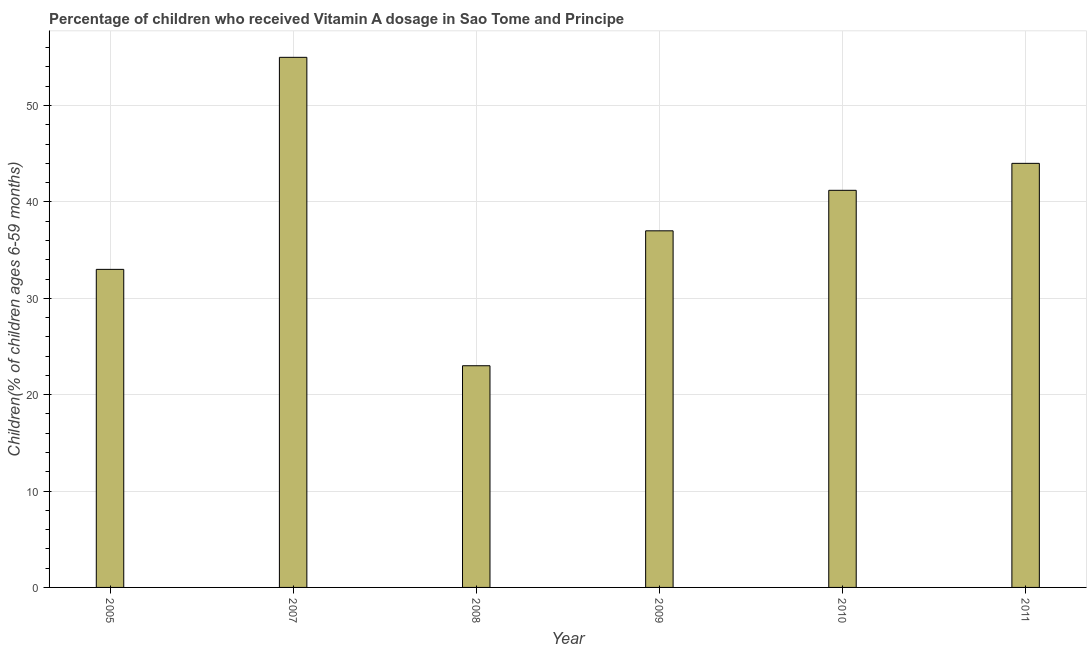What is the title of the graph?
Provide a short and direct response. Percentage of children who received Vitamin A dosage in Sao Tome and Principe. What is the label or title of the Y-axis?
Offer a terse response. Children(% of children ages 6-59 months). In which year was the vitamin a supplementation coverage rate maximum?
Provide a succinct answer. 2007. In which year was the vitamin a supplementation coverage rate minimum?
Ensure brevity in your answer.  2008. What is the sum of the vitamin a supplementation coverage rate?
Give a very brief answer. 233.2. What is the difference between the vitamin a supplementation coverage rate in 2009 and 2011?
Provide a succinct answer. -7. What is the average vitamin a supplementation coverage rate per year?
Keep it short and to the point. 38.87. What is the median vitamin a supplementation coverage rate?
Give a very brief answer. 39.1. What is the ratio of the vitamin a supplementation coverage rate in 2005 to that in 2009?
Provide a short and direct response. 0.89. Is the vitamin a supplementation coverage rate in 2005 less than that in 2010?
Provide a succinct answer. Yes. What is the difference between the highest and the lowest vitamin a supplementation coverage rate?
Your answer should be very brief. 32. In how many years, is the vitamin a supplementation coverage rate greater than the average vitamin a supplementation coverage rate taken over all years?
Your response must be concise. 3. How many years are there in the graph?
Offer a terse response. 6. What is the difference between two consecutive major ticks on the Y-axis?
Offer a very short reply. 10. What is the Children(% of children ages 6-59 months) of 2005?
Offer a very short reply. 33. What is the Children(% of children ages 6-59 months) in 2007?
Give a very brief answer. 55. What is the Children(% of children ages 6-59 months) in 2008?
Give a very brief answer. 23. What is the Children(% of children ages 6-59 months) of 2009?
Your answer should be compact. 37. What is the Children(% of children ages 6-59 months) in 2010?
Your response must be concise. 41.2. What is the difference between the Children(% of children ages 6-59 months) in 2005 and 2009?
Provide a short and direct response. -4. What is the difference between the Children(% of children ages 6-59 months) in 2005 and 2010?
Your response must be concise. -8.2. What is the difference between the Children(% of children ages 6-59 months) in 2005 and 2011?
Offer a very short reply. -11. What is the difference between the Children(% of children ages 6-59 months) in 2007 and 2008?
Provide a succinct answer. 32. What is the difference between the Children(% of children ages 6-59 months) in 2007 and 2009?
Your answer should be very brief. 18. What is the difference between the Children(% of children ages 6-59 months) in 2007 and 2010?
Give a very brief answer. 13.8. What is the difference between the Children(% of children ages 6-59 months) in 2008 and 2009?
Keep it short and to the point. -14. What is the difference between the Children(% of children ages 6-59 months) in 2008 and 2010?
Offer a very short reply. -18.2. What is the difference between the Children(% of children ages 6-59 months) in 2008 and 2011?
Keep it short and to the point. -21. What is the difference between the Children(% of children ages 6-59 months) in 2009 and 2010?
Keep it short and to the point. -4.2. What is the difference between the Children(% of children ages 6-59 months) in 2009 and 2011?
Give a very brief answer. -7. What is the difference between the Children(% of children ages 6-59 months) in 2010 and 2011?
Provide a short and direct response. -2.8. What is the ratio of the Children(% of children ages 6-59 months) in 2005 to that in 2007?
Give a very brief answer. 0.6. What is the ratio of the Children(% of children ages 6-59 months) in 2005 to that in 2008?
Provide a short and direct response. 1.44. What is the ratio of the Children(% of children ages 6-59 months) in 2005 to that in 2009?
Your response must be concise. 0.89. What is the ratio of the Children(% of children ages 6-59 months) in 2005 to that in 2010?
Your response must be concise. 0.8. What is the ratio of the Children(% of children ages 6-59 months) in 2007 to that in 2008?
Keep it short and to the point. 2.39. What is the ratio of the Children(% of children ages 6-59 months) in 2007 to that in 2009?
Provide a short and direct response. 1.49. What is the ratio of the Children(% of children ages 6-59 months) in 2007 to that in 2010?
Your answer should be very brief. 1.33. What is the ratio of the Children(% of children ages 6-59 months) in 2008 to that in 2009?
Offer a terse response. 0.62. What is the ratio of the Children(% of children ages 6-59 months) in 2008 to that in 2010?
Your answer should be very brief. 0.56. What is the ratio of the Children(% of children ages 6-59 months) in 2008 to that in 2011?
Your answer should be compact. 0.52. What is the ratio of the Children(% of children ages 6-59 months) in 2009 to that in 2010?
Offer a terse response. 0.9. What is the ratio of the Children(% of children ages 6-59 months) in 2009 to that in 2011?
Offer a very short reply. 0.84. What is the ratio of the Children(% of children ages 6-59 months) in 2010 to that in 2011?
Offer a very short reply. 0.94. 